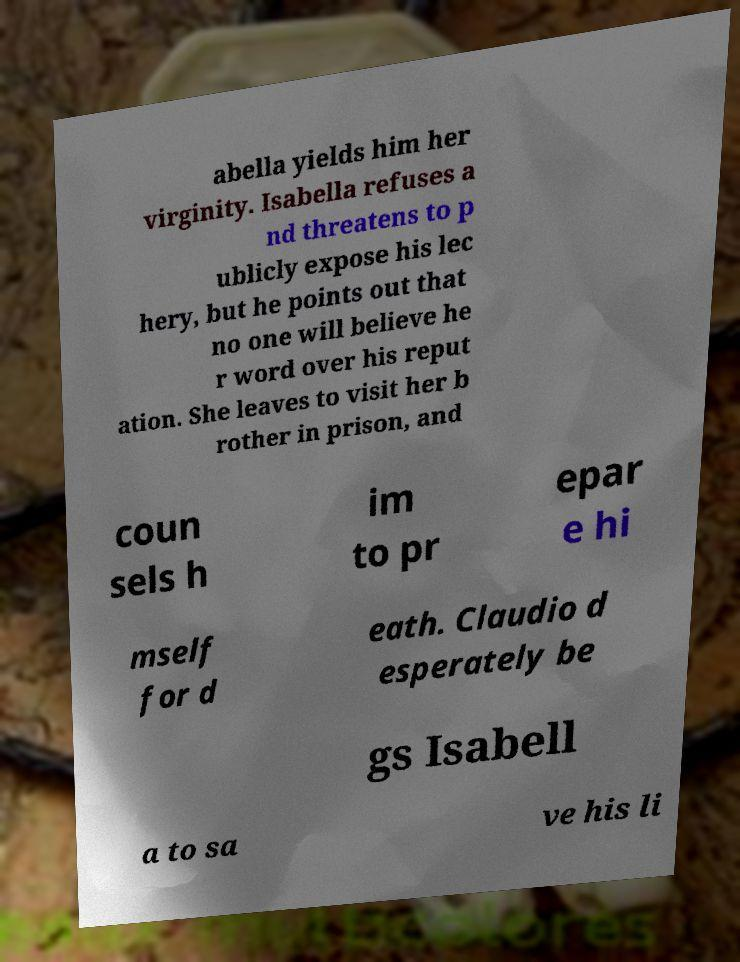I need the written content from this picture converted into text. Can you do that? abella yields him her virginity. Isabella refuses a nd threatens to p ublicly expose his lec hery, but he points out that no one will believe he r word over his reput ation. She leaves to visit her b rother in prison, and coun sels h im to pr epar e hi mself for d eath. Claudio d esperately be gs Isabell a to sa ve his li 